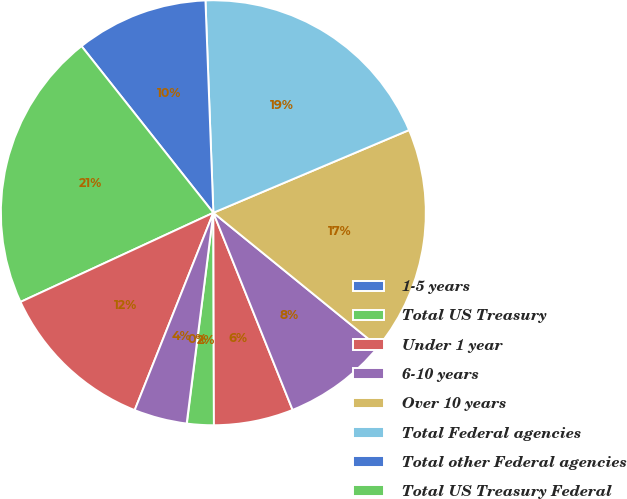Convert chart to OTSL. <chart><loc_0><loc_0><loc_500><loc_500><pie_chart><fcel>1-5 years<fcel>Total US Treasury<fcel>Under 1 year<fcel>6-10 years<fcel>Over 10 years<fcel>Total Federal agencies<fcel>Total other Federal agencies<fcel>Total US Treasury Federal<fcel>Total municipal securities<fcel>Total private label CMO<nl><fcel>0.02%<fcel>2.03%<fcel>6.04%<fcel>8.05%<fcel>17.23%<fcel>19.23%<fcel>10.06%<fcel>21.24%<fcel>12.07%<fcel>4.03%<nl></chart> 